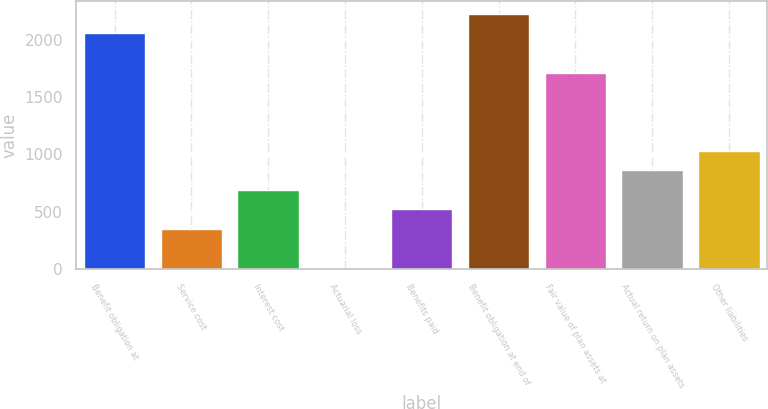Convert chart. <chart><loc_0><loc_0><loc_500><loc_500><bar_chart><fcel>Benefit obligation at<fcel>Service cost<fcel>Interest cost<fcel>Actuarial loss<fcel>Benefits paid<fcel>Benefit obligation at end of<fcel>Fair value of plan assets at<fcel>Actual return on plan assets<fcel>Other liabilities<nl><fcel>2052.9<fcel>348.9<fcel>689.7<fcel>8.1<fcel>519.3<fcel>2223.3<fcel>1712.1<fcel>860.1<fcel>1030.5<nl></chart> 